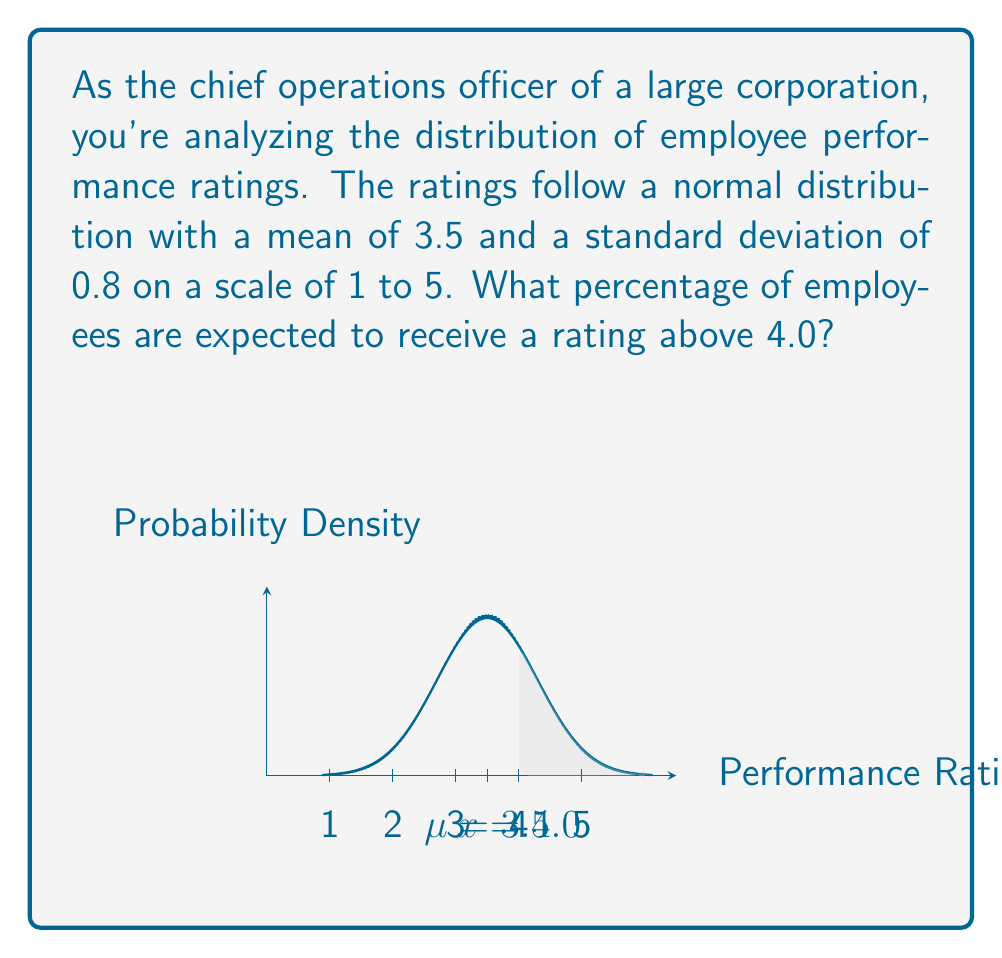Could you help me with this problem? To solve this problem, we need to use the properties of the normal distribution and the concept of z-scores. Let's follow these steps:

1) First, we calculate the z-score for the rating of 4.0. The z-score formula is:

   $$z = \frac{x - \mu}{\sigma}$$

   where $x$ is the value of interest, $\mu$ is the mean, and $\sigma$ is the standard deviation.

2) Plugging in our values:

   $$z = \frac{4.0 - 3.5}{0.8} = \frac{0.5}{0.8} = 0.625$$

3) Now that we have the z-score, we need to find the area to the right of this z-score in the standard normal distribution. This represents the probability of an employee receiving a rating above 4.0.

4) We can use a standard normal distribution table or a calculator for this. The area to the right of z = 0.625 is approximately 0.2660.

5) To convert this to a percentage, we multiply by 100:

   0.2660 * 100 = 26.60%

Therefore, approximately 26.60% of employees are expected to receive a rating above 4.0.
Answer: 26.60% 